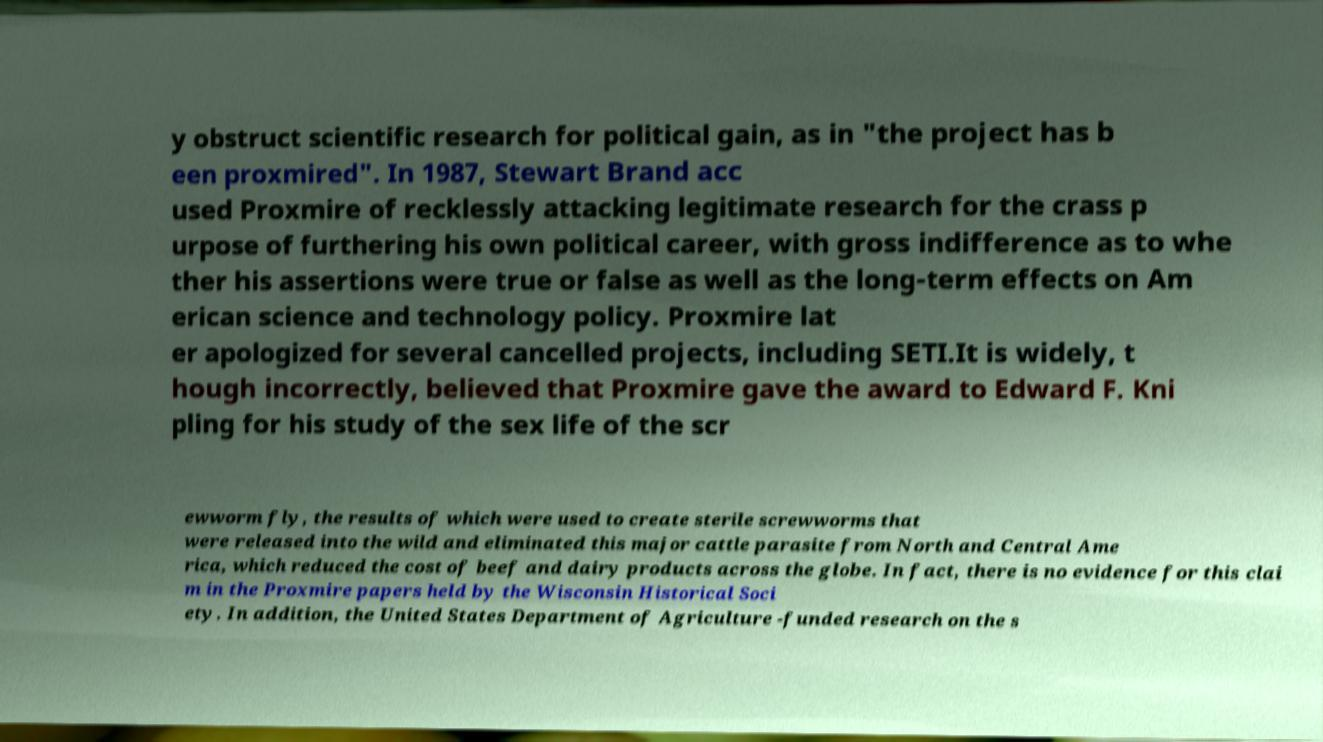Please read and relay the text visible in this image. What does it say? y obstruct scientific research for political gain, as in "the project has b een proxmired". In 1987, Stewart Brand acc used Proxmire of recklessly attacking legitimate research for the crass p urpose of furthering his own political career, with gross indifference as to whe ther his assertions were true or false as well as the long-term effects on Am erican science and technology policy. Proxmire lat er apologized for several cancelled projects, including SETI.It is widely, t hough incorrectly, believed that Proxmire gave the award to Edward F. Kni pling for his study of the sex life of the scr ewworm fly, the results of which were used to create sterile screwworms that were released into the wild and eliminated this major cattle parasite from North and Central Ame rica, which reduced the cost of beef and dairy products across the globe. In fact, there is no evidence for this clai m in the Proxmire papers held by the Wisconsin Historical Soci ety. In addition, the United States Department of Agriculture -funded research on the s 